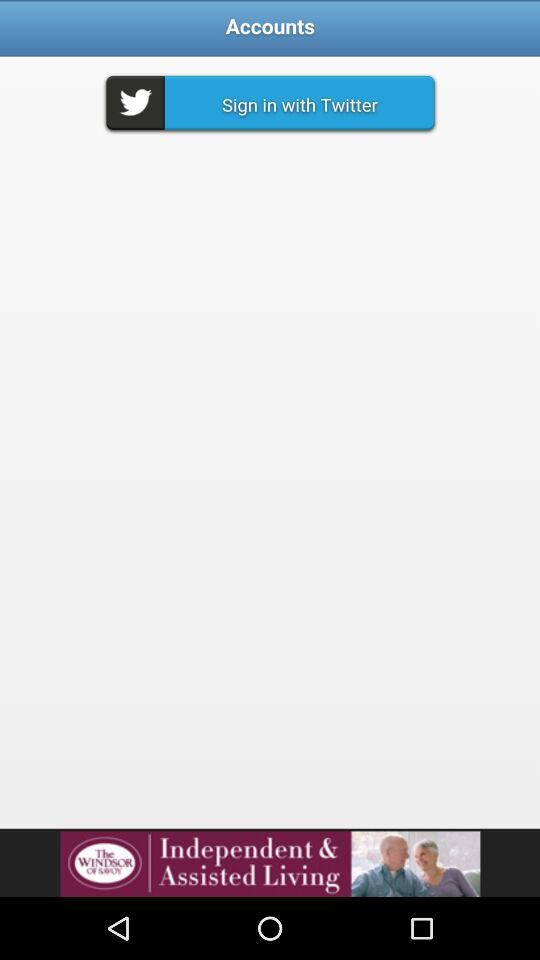What accounts can I use to sign in? You can use "Twitter" to sign in. 